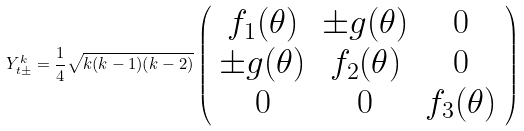<formula> <loc_0><loc_0><loc_500><loc_500>Y _ { t \pm } ^ { k } = \frac { 1 } { 4 } \sqrt { k ( k - 1 ) ( k - 2 ) } \left ( \begin{array} { c c c } f _ { 1 } ( \theta ) & \pm g ( \theta ) & 0 \\ \pm g ( \theta ) & f _ { 2 } ( \theta ) & 0 \\ 0 & 0 & f _ { 3 } ( \theta ) \end{array} \right )</formula> 